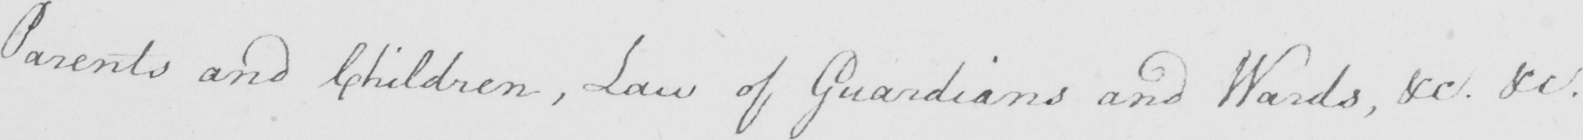Please provide the text content of this handwritten line. Parents and Children , Law of Guardians and Wards , &c . &c . 